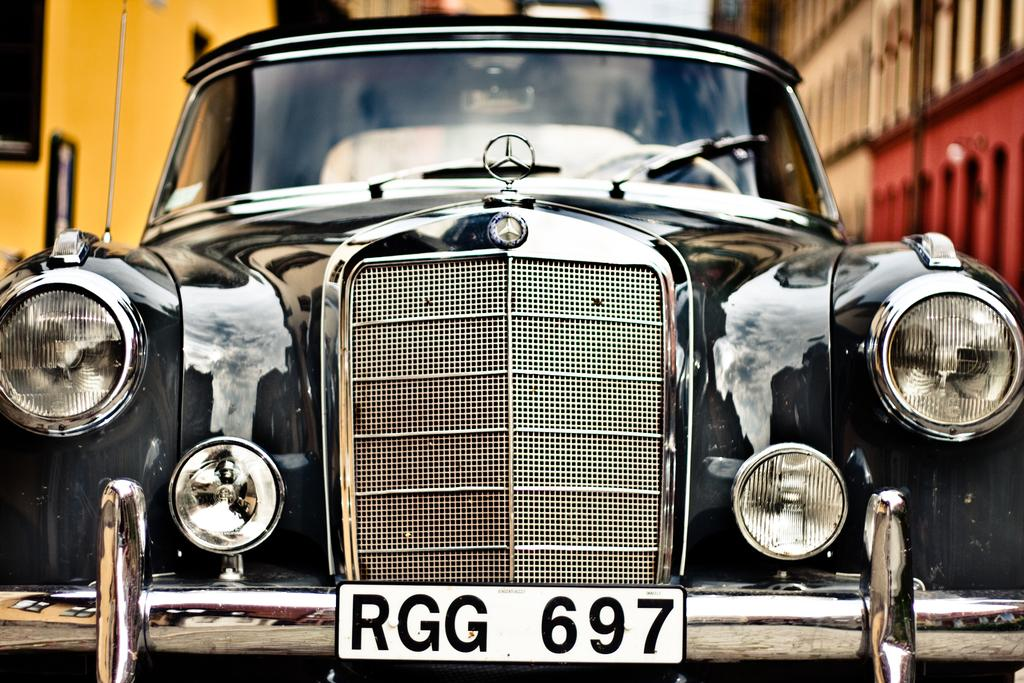What is the main subject of the image? There is a car in the image. What can be seen in the background of the image? There are buildings and the sky visible in the background of the image. What type of frame is the sister holding in the image? There is no sister or frame present in the image. 